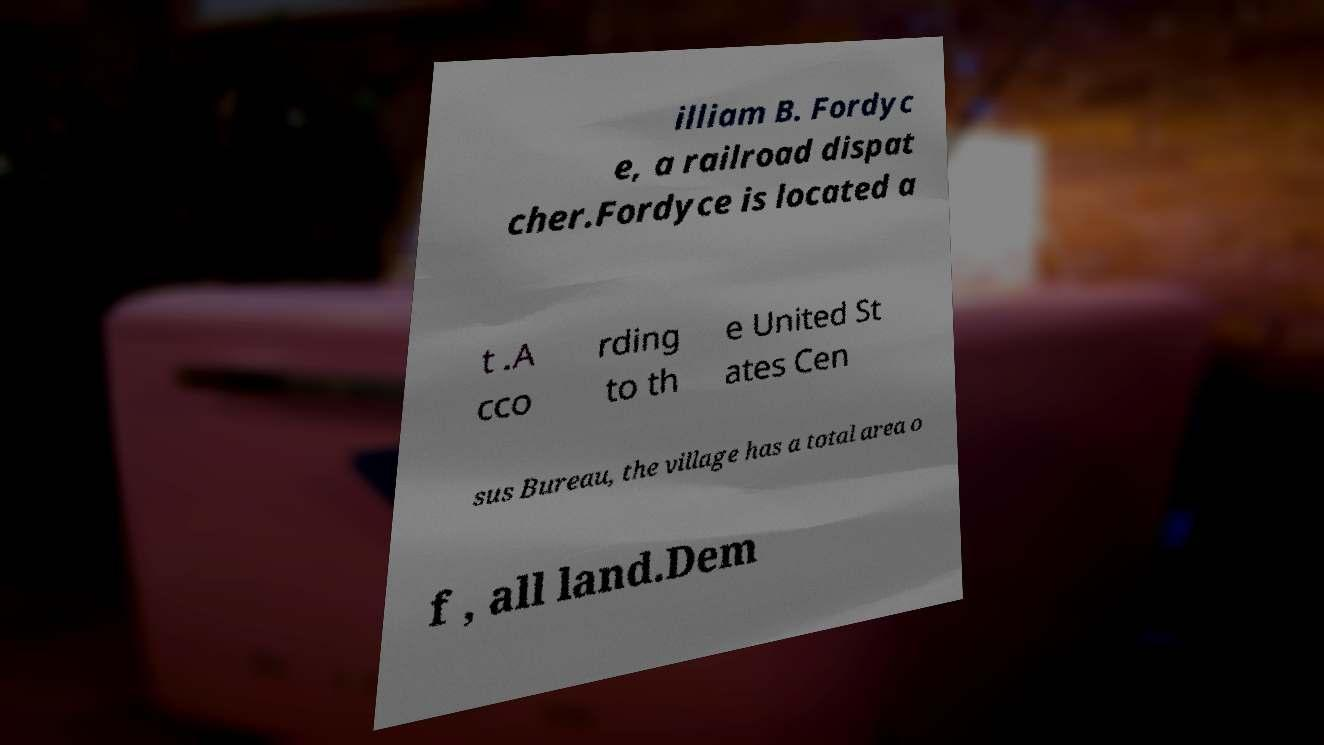Could you extract and type out the text from this image? illiam B. Fordyc e, a railroad dispat cher.Fordyce is located a t .A cco rding to th e United St ates Cen sus Bureau, the village has a total area o f , all land.Dem 